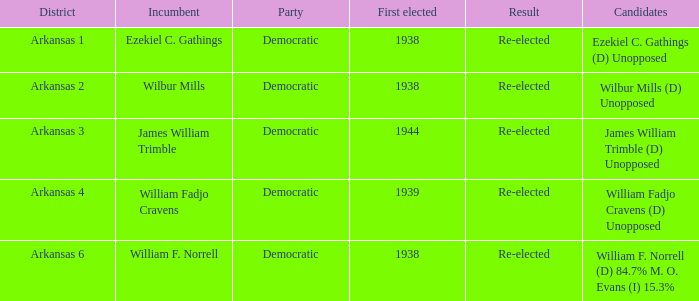Which party has a first elected number bigger than 1939.0? Democratic. 